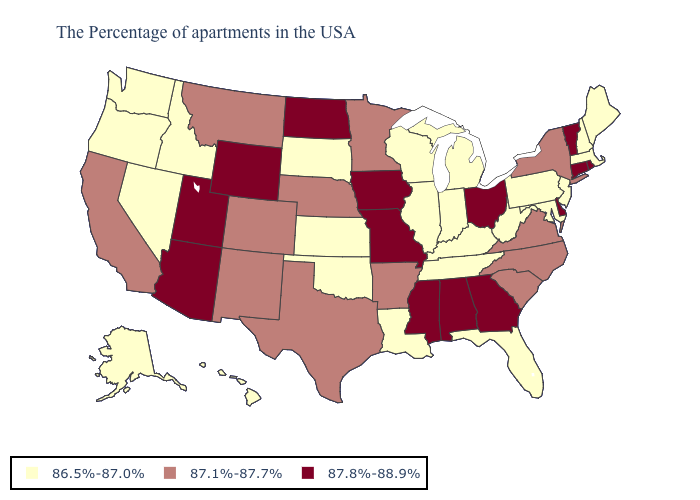Among the states that border Idaho , does Oregon have the highest value?
Answer briefly. No. How many symbols are there in the legend?
Write a very short answer. 3. Which states have the lowest value in the West?
Short answer required. Idaho, Nevada, Washington, Oregon, Alaska, Hawaii. Which states have the lowest value in the West?
Quick response, please. Idaho, Nevada, Washington, Oregon, Alaska, Hawaii. Does the map have missing data?
Short answer required. No. What is the lowest value in the Northeast?
Write a very short answer. 86.5%-87.0%. What is the lowest value in the USA?
Give a very brief answer. 86.5%-87.0%. What is the lowest value in states that border Tennessee?
Concise answer only. 86.5%-87.0%. Name the states that have a value in the range 87.8%-88.9%?
Write a very short answer. Rhode Island, Vermont, Connecticut, Delaware, Ohio, Georgia, Alabama, Mississippi, Missouri, Iowa, North Dakota, Wyoming, Utah, Arizona. Among the states that border Texas , does Louisiana have the lowest value?
Be succinct. Yes. What is the value of Nebraska?
Give a very brief answer. 87.1%-87.7%. Which states hav the highest value in the West?
Short answer required. Wyoming, Utah, Arizona. What is the lowest value in the South?
Answer briefly. 86.5%-87.0%. What is the lowest value in the USA?
Keep it brief. 86.5%-87.0%. 